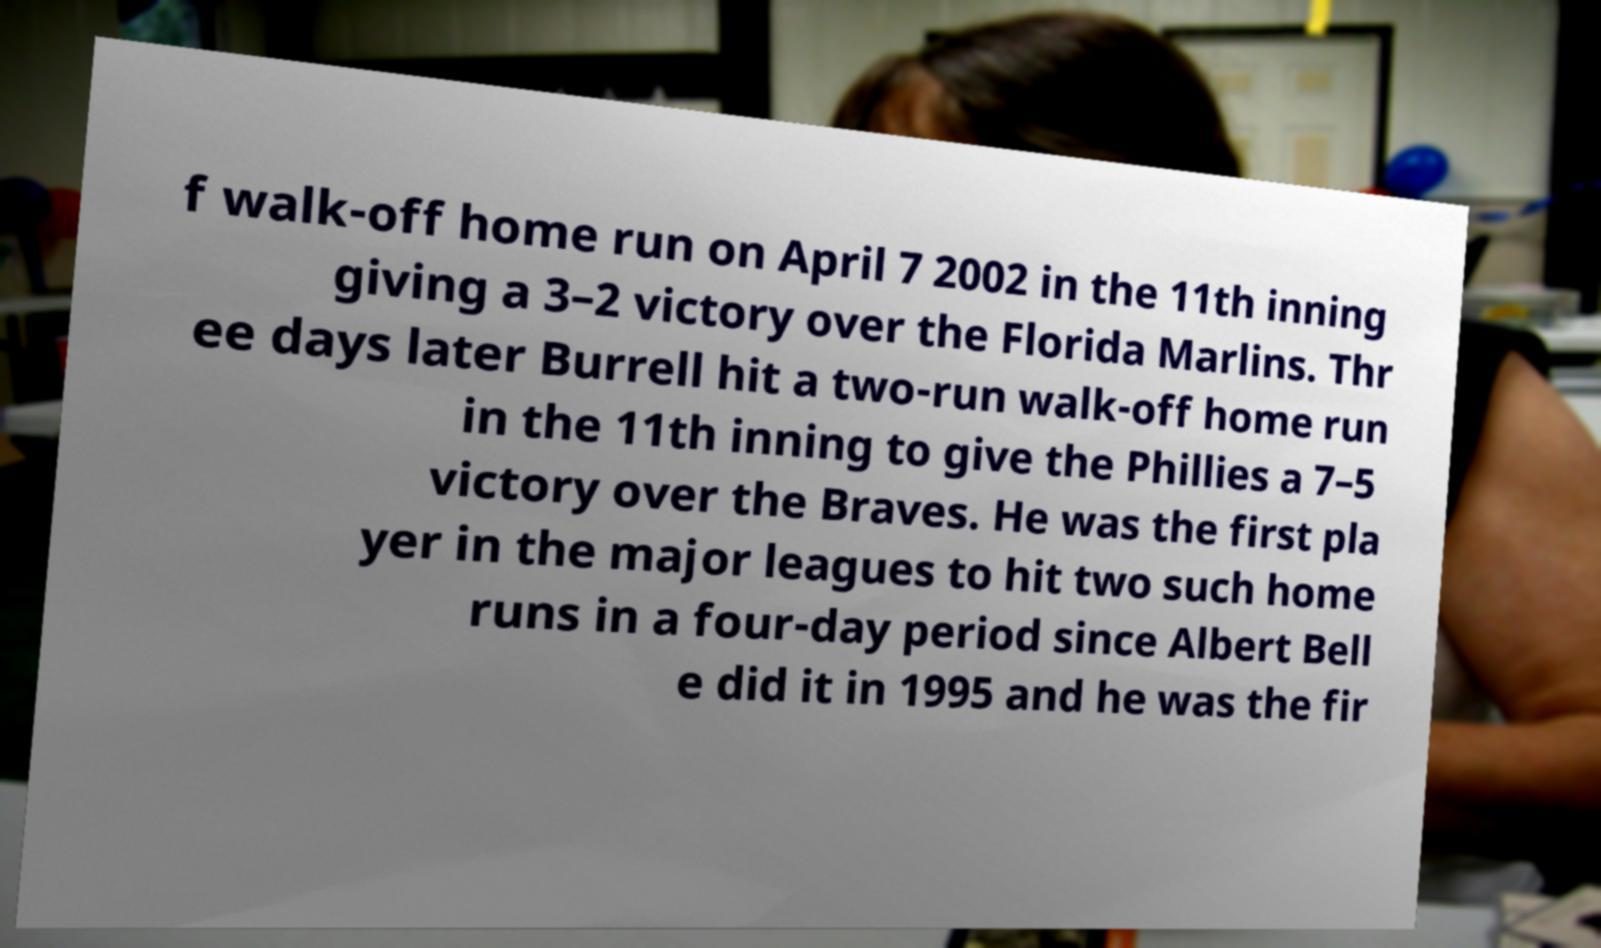I need the written content from this picture converted into text. Can you do that? f walk-off home run on April 7 2002 in the 11th inning giving a 3–2 victory over the Florida Marlins. Thr ee days later Burrell hit a two-run walk-off home run in the 11th inning to give the Phillies a 7–5 victory over the Braves. He was the first pla yer in the major leagues to hit two such home runs in a four-day period since Albert Bell e did it in 1995 and he was the fir 